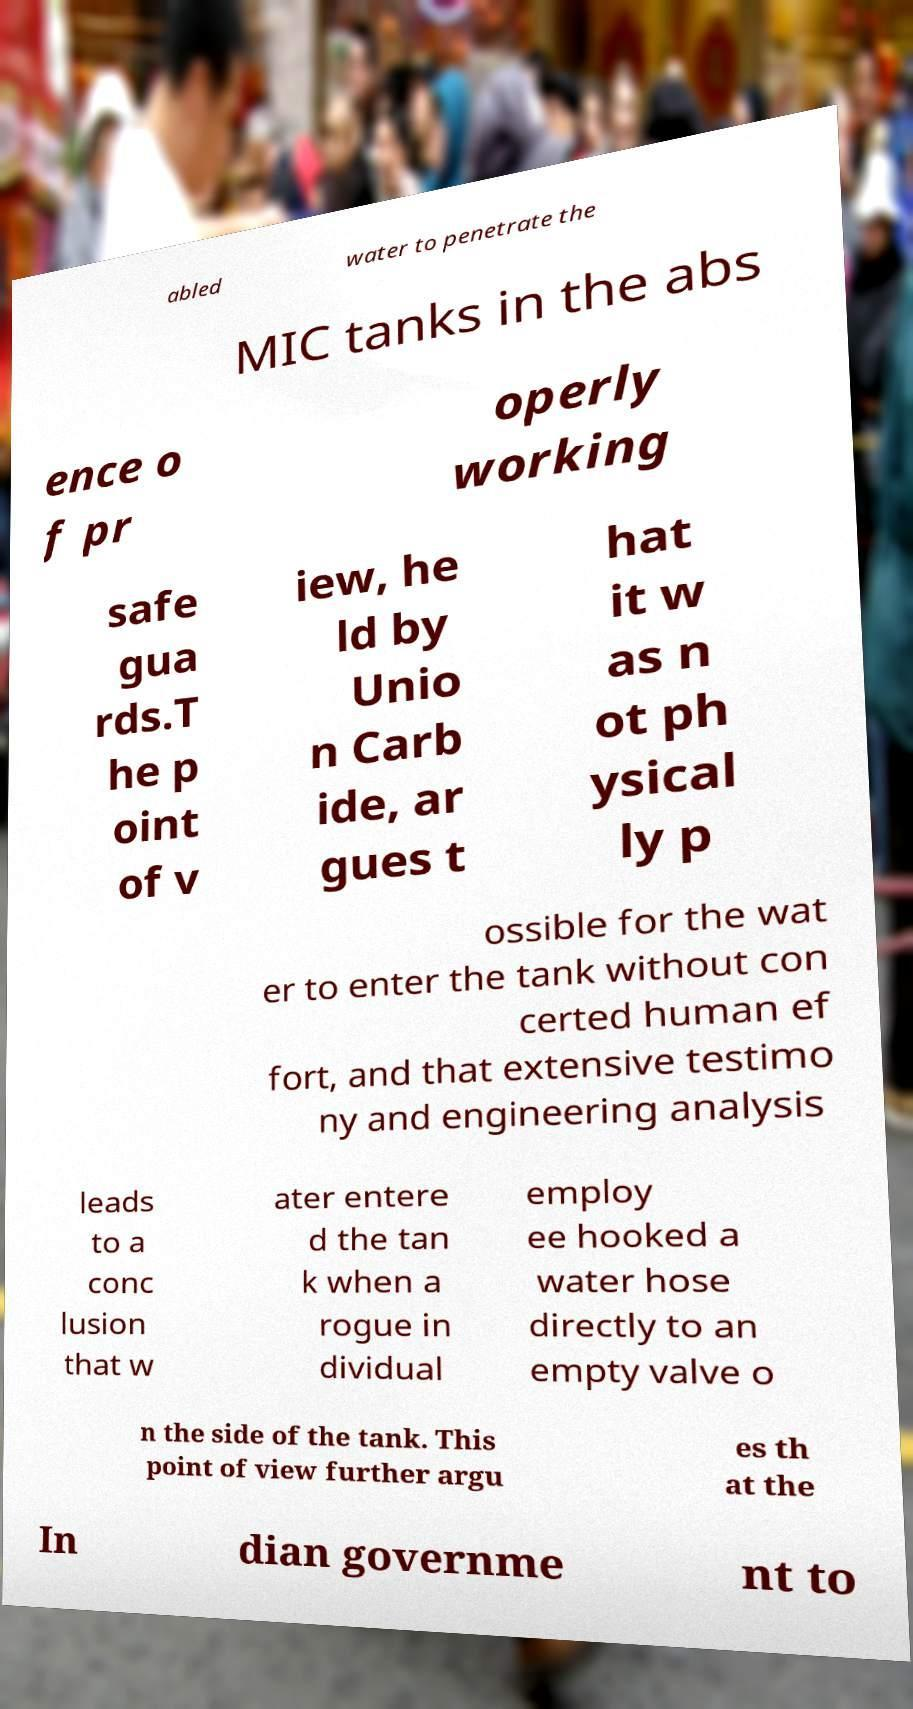Please identify and transcribe the text found in this image. abled water to penetrate the MIC tanks in the abs ence o f pr operly working safe gua rds.T he p oint of v iew, he ld by Unio n Carb ide, ar gues t hat it w as n ot ph ysical ly p ossible for the wat er to enter the tank without con certed human ef fort, and that extensive testimo ny and engineering analysis leads to a conc lusion that w ater entere d the tan k when a rogue in dividual employ ee hooked a water hose directly to an empty valve o n the side of the tank. This point of view further argu es th at the In dian governme nt to 